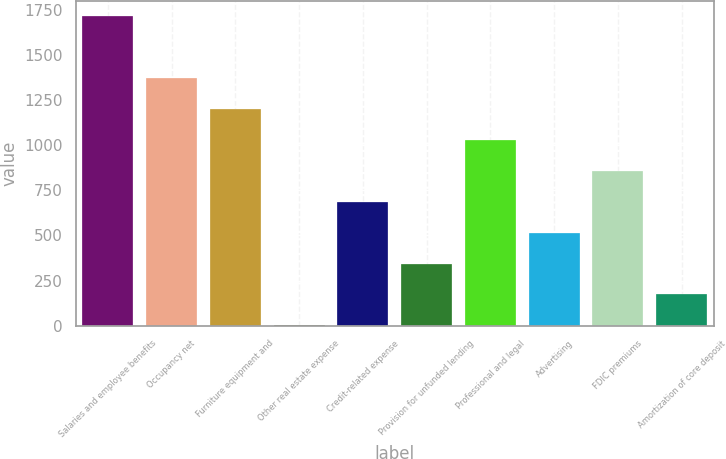Convert chart to OTSL. <chart><loc_0><loc_0><loc_500><loc_500><bar_chart><fcel>Salaries and employee benefits<fcel>Occupancy net<fcel>Furniture equipment and<fcel>Other real estate expense<fcel>Credit-related expense<fcel>Provision for unfunded lending<fcel>Professional and legal<fcel>Advertising<fcel>FDIC premiums<fcel>Amortization of core deposit<nl><fcel>1714.4<fcel>1371.86<fcel>1200.59<fcel>1.7<fcel>686.78<fcel>344.24<fcel>1029.32<fcel>515.51<fcel>858.05<fcel>172.97<nl></chart> 